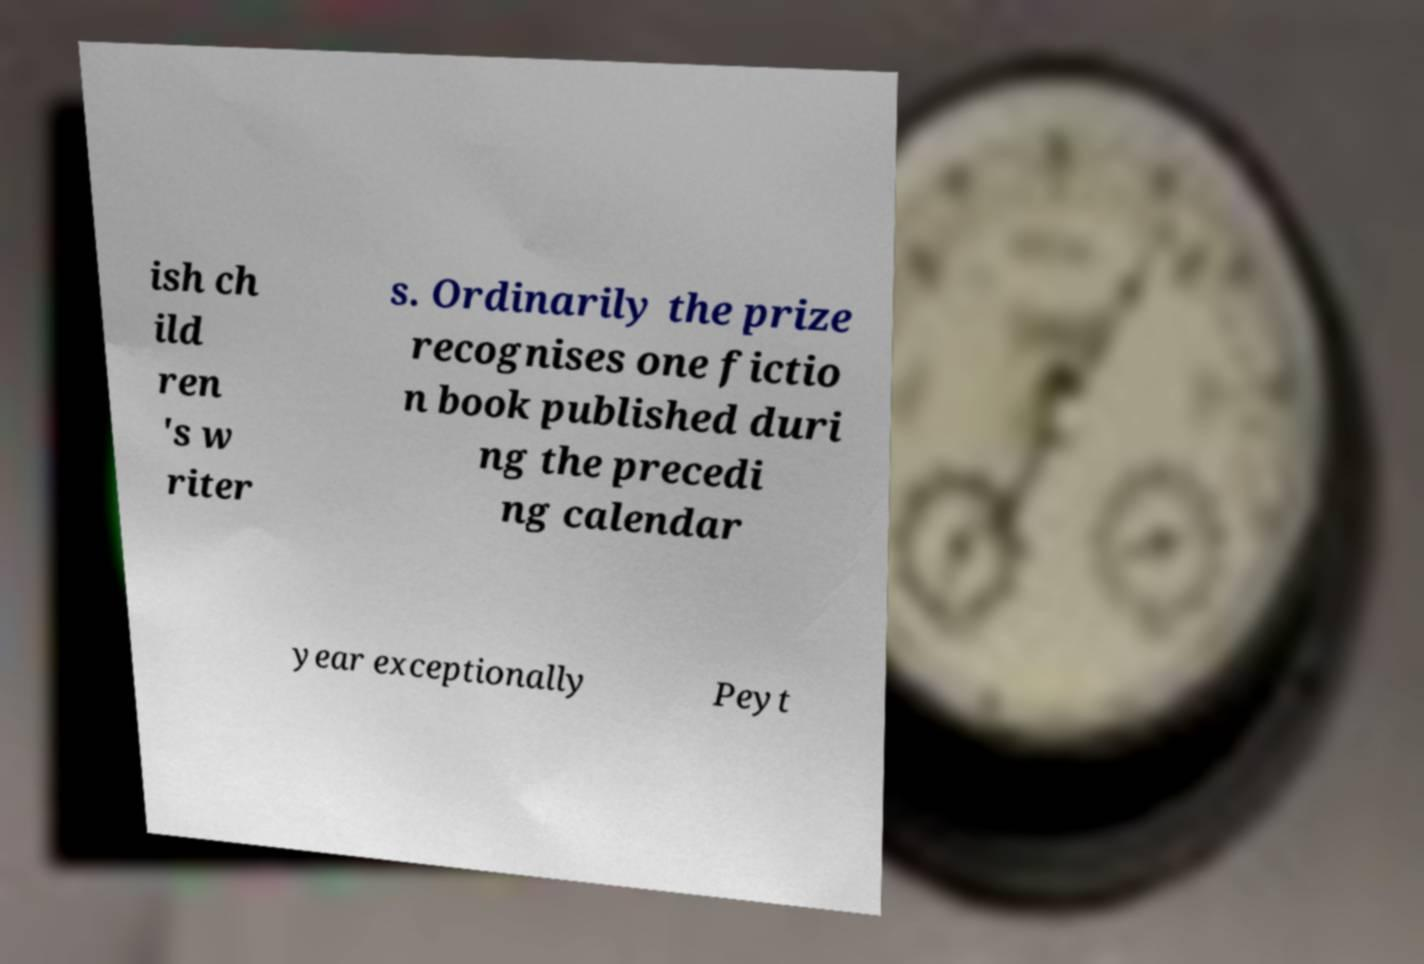I need the written content from this picture converted into text. Can you do that? ish ch ild ren 's w riter s. Ordinarily the prize recognises one fictio n book published duri ng the precedi ng calendar year exceptionally Peyt 